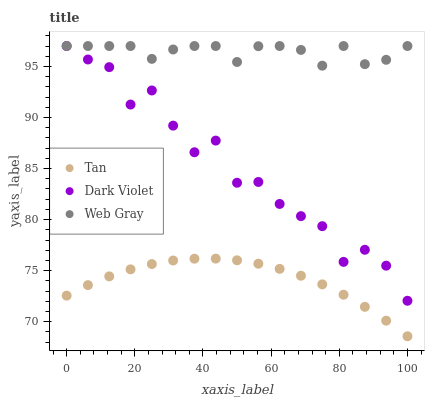Does Tan have the minimum area under the curve?
Answer yes or no. Yes. Does Web Gray have the maximum area under the curve?
Answer yes or no. Yes. Does Dark Violet have the minimum area under the curve?
Answer yes or no. No. Does Dark Violet have the maximum area under the curve?
Answer yes or no. No. Is Tan the smoothest?
Answer yes or no. Yes. Is Dark Violet the roughest?
Answer yes or no. Yes. Is Web Gray the smoothest?
Answer yes or no. No. Is Web Gray the roughest?
Answer yes or no. No. Does Tan have the lowest value?
Answer yes or no. Yes. Does Dark Violet have the lowest value?
Answer yes or no. No. Does Dark Violet have the highest value?
Answer yes or no. Yes. Is Tan less than Web Gray?
Answer yes or no. Yes. Is Web Gray greater than Tan?
Answer yes or no. Yes. Does Web Gray intersect Dark Violet?
Answer yes or no. Yes. Is Web Gray less than Dark Violet?
Answer yes or no. No. Is Web Gray greater than Dark Violet?
Answer yes or no. No. Does Tan intersect Web Gray?
Answer yes or no. No. 